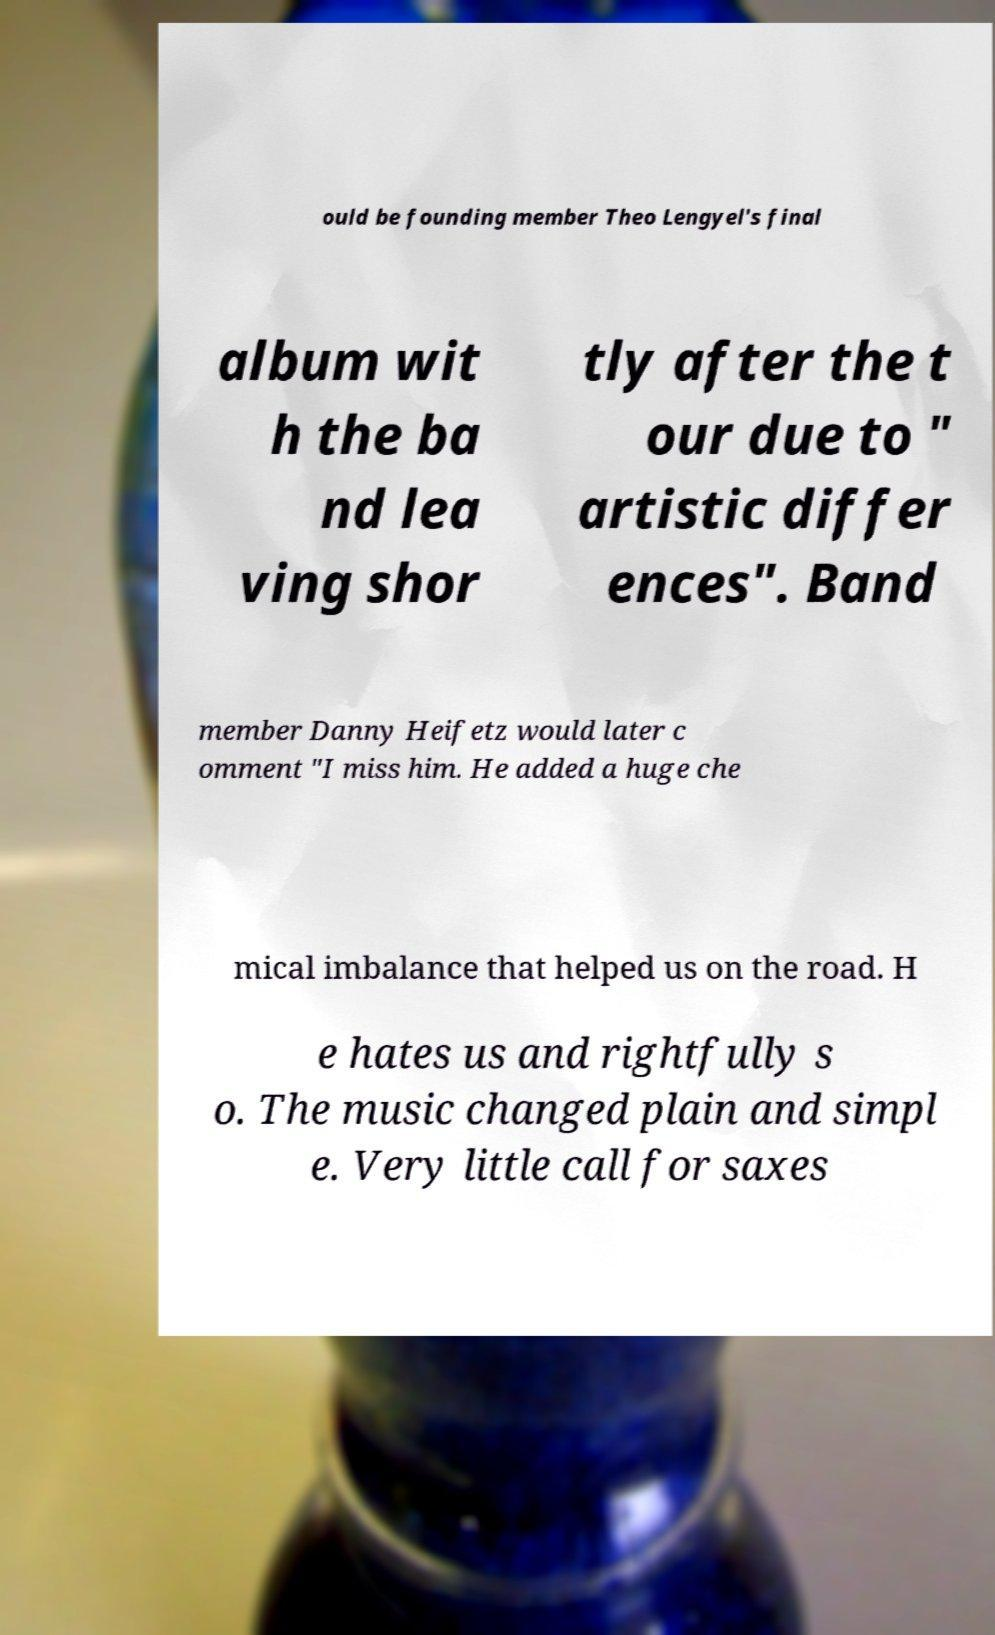What messages or text are displayed in this image? I need them in a readable, typed format. ould be founding member Theo Lengyel's final album wit h the ba nd lea ving shor tly after the t our due to " artistic differ ences". Band member Danny Heifetz would later c omment "I miss him. He added a huge che mical imbalance that helped us on the road. H e hates us and rightfully s o. The music changed plain and simpl e. Very little call for saxes 